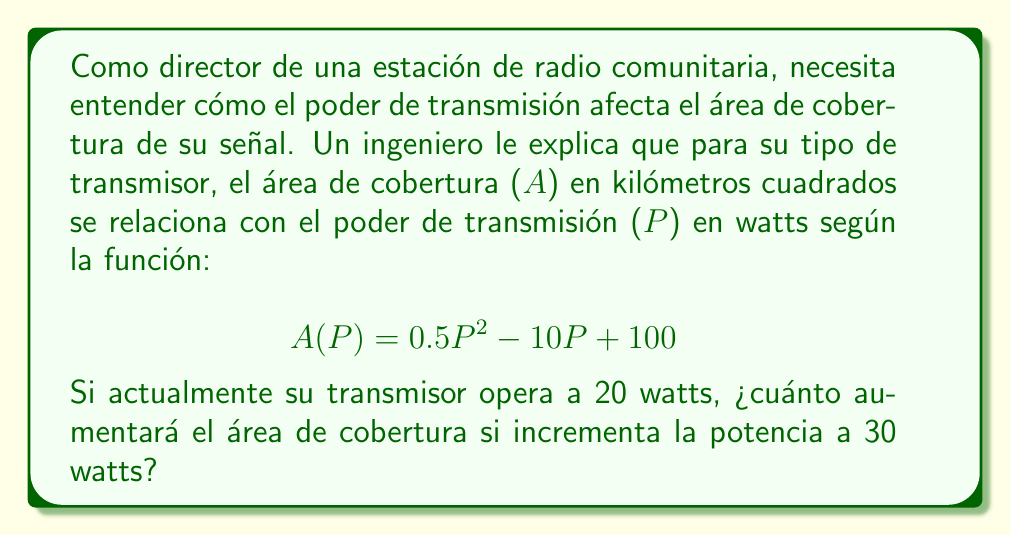Could you help me with this problem? Para resolver este problema, seguiremos estos pasos:

1) Primero, calculamos el área de cobertura actual con 20 watts:
   $$ A(20) = 0.5(20)^2 - 10(20) + 100 $$
   $$ = 0.5(400) - 200 + 100 $$
   $$ = 200 - 200 + 100 = 100 \text{ km}^2 $$

2) Luego, calculamos el área de cobertura con 30 watts:
   $$ A(30) = 0.5(30)^2 - 10(30) + 100 $$
   $$ = 0.5(900) - 300 + 100 $$
   $$ = 450 - 300 + 100 = 250 \text{ km}^2 $$

3) Finalmente, calculamos la diferencia entre las dos áreas:
   $$ 250 \text{ km}^2 - 100 \text{ km}^2 = 150 \text{ km}^2 $$

Por lo tanto, el área de cobertura aumentará en 150 kilómetros cuadrados.
Answer: El área de cobertura aumentará en 150 km². 